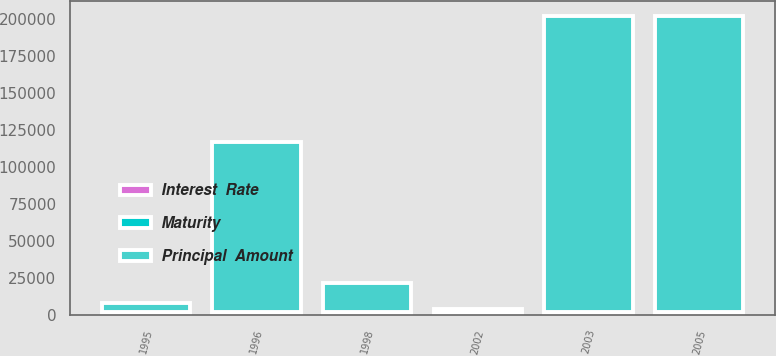Convert chart. <chart><loc_0><loc_0><loc_500><loc_500><stacked_bar_chart><ecel><fcel>1996<fcel>1998<fcel>1995<fcel>2005<fcel>2002<fcel>2003<nl><fcel>Interest  Rate<fcel>2006<fcel>2006<fcel>2010<fcel>2010<fcel>2012<fcel>2015<nl><fcel>Principal  Amount<fcel>115000<fcel>20000<fcel>6421<fcel>200000<fcel>2010<fcel>200000<nl><fcel>Maturity<fcel>6.5<fcel>7.88<fcel>6.62<fcel>4.88<fcel>6.45<fcel>6<nl></chart> 